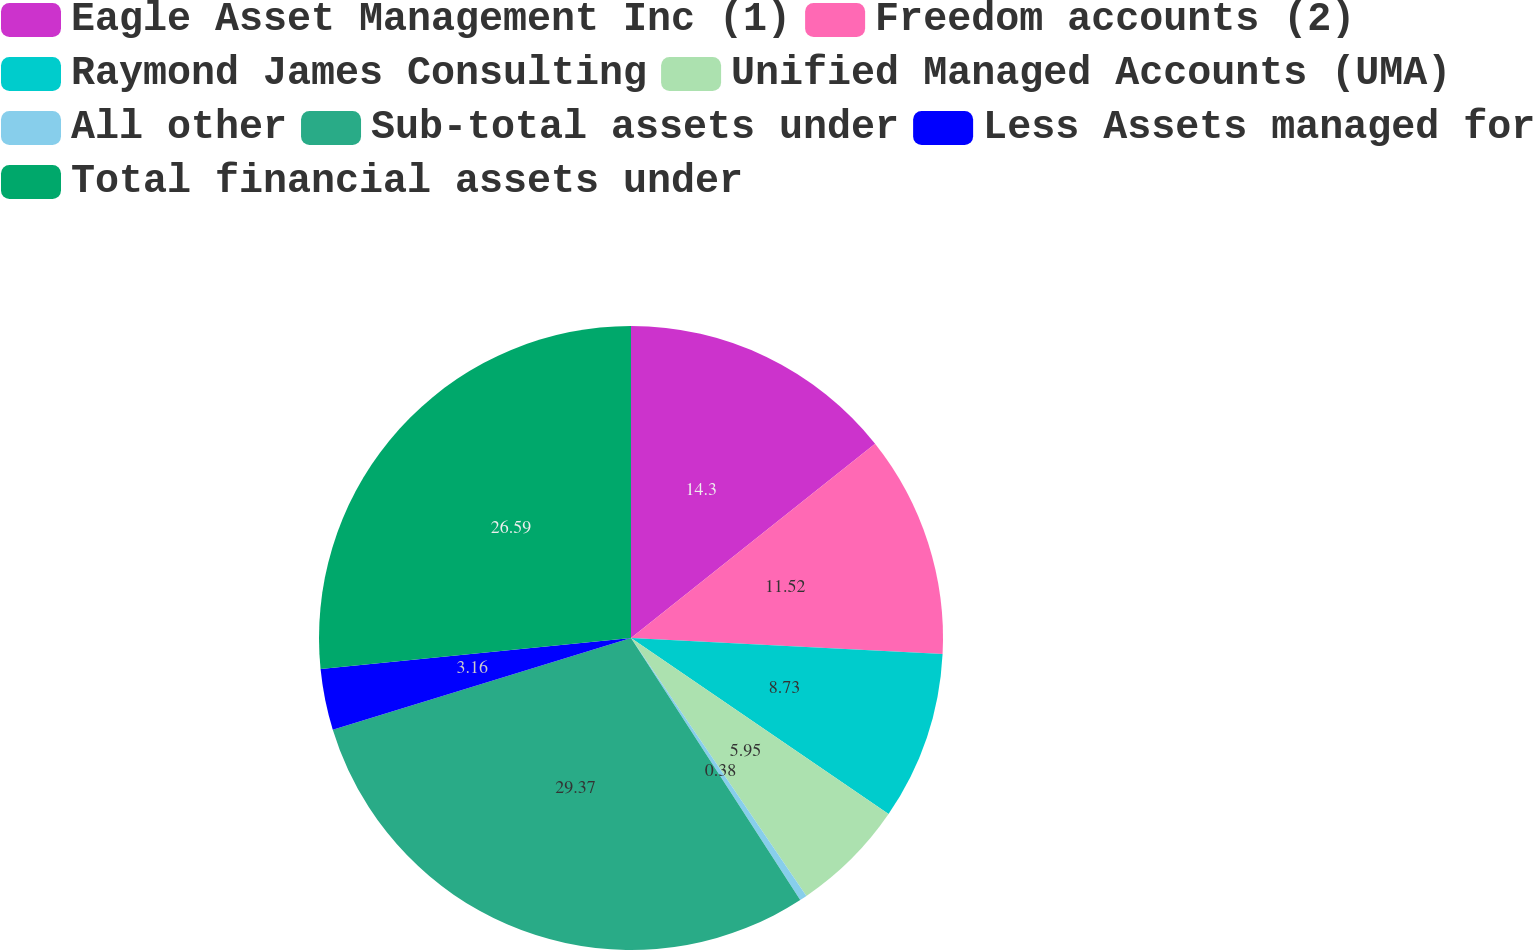Convert chart. <chart><loc_0><loc_0><loc_500><loc_500><pie_chart><fcel>Eagle Asset Management Inc (1)<fcel>Freedom accounts (2)<fcel>Raymond James Consulting<fcel>Unified Managed Accounts (UMA)<fcel>All other<fcel>Sub-total assets under<fcel>Less Assets managed for<fcel>Total financial assets under<nl><fcel>14.3%<fcel>11.52%<fcel>8.73%<fcel>5.95%<fcel>0.38%<fcel>29.38%<fcel>3.16%<fcel>26.59%<nl></chart> 